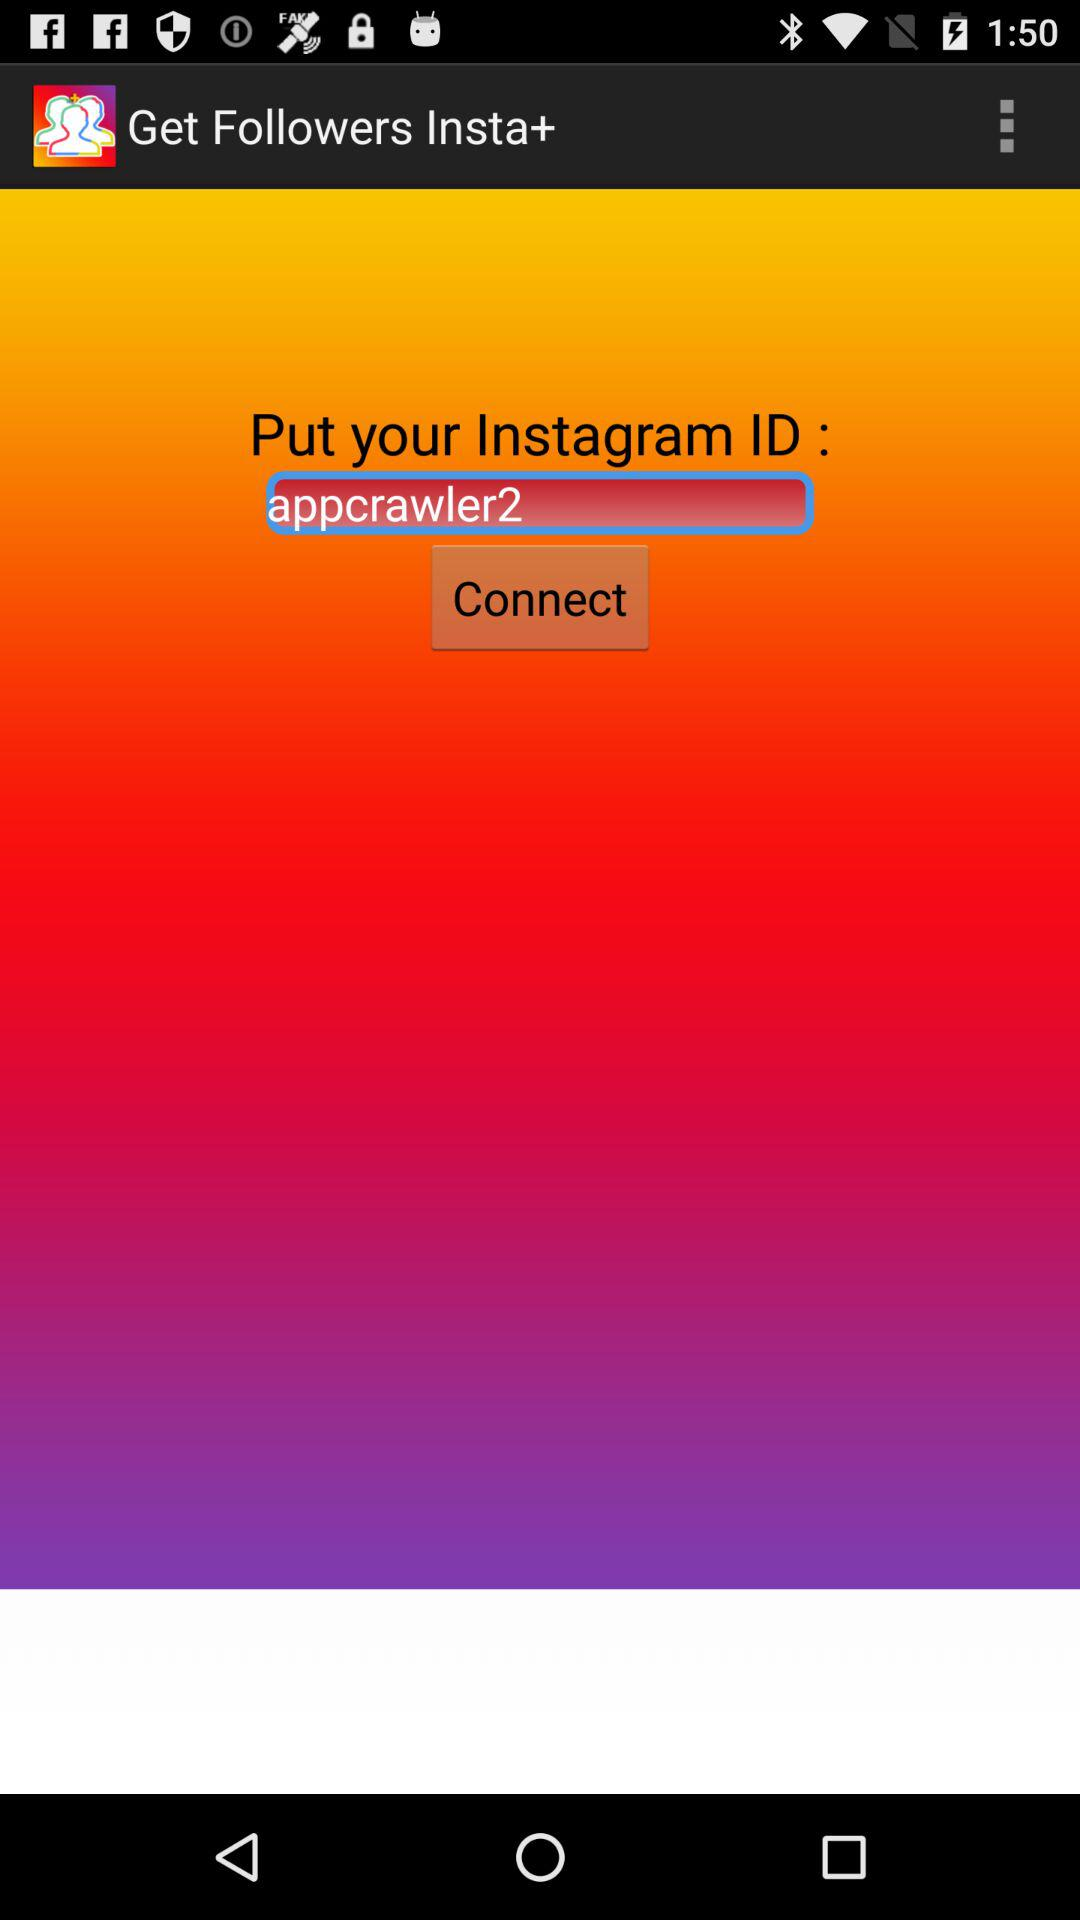What is the "Instagram" ID? The "Instagram" ID is "appcrawler2". 